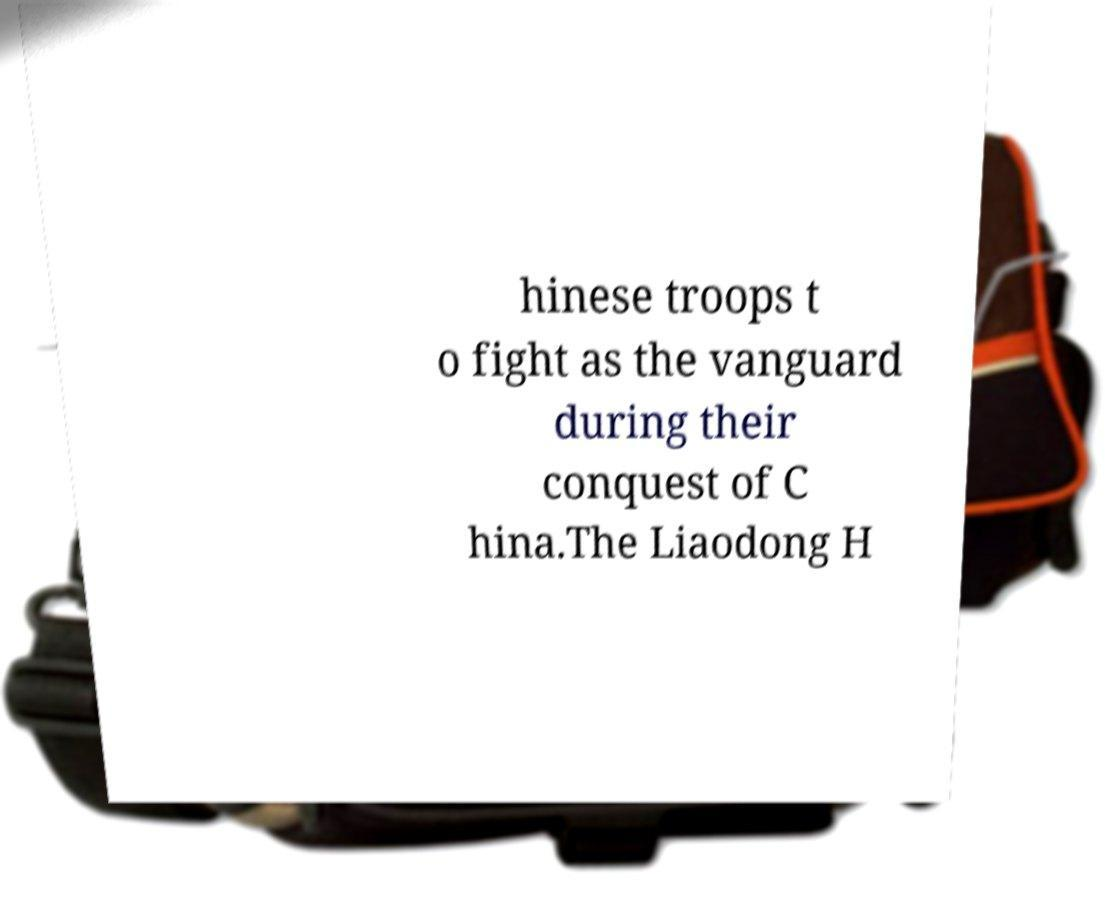Please identify and transcribe the text found in this image. hinese troops t o fight as the vanguard during their conquest of C hina.The Liaodong H 